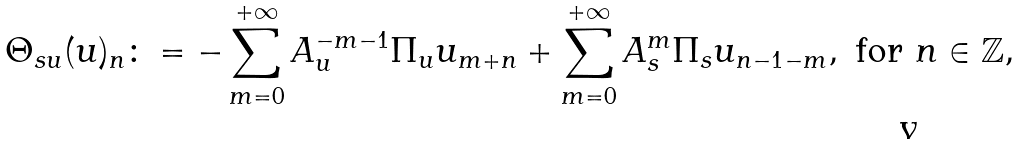Convert formula to latex. <formula><loc_0><loc_0><loc_500><loc_500>\Theta _ { s u } ( u ) _ { n } \colon = - \sum _ { m = 0 } ^ { + \infty } A _ { u } ^ { - m - 1 } \Pi _ { u } u _ { m + n } + \sum _ { m = 0 } ^ { + \infty } A _ { s } ^ { m } \Pi _ { s } u _ { n - 1 - m } , \text { for } n \in \mathbb { Z } ,</formula> 